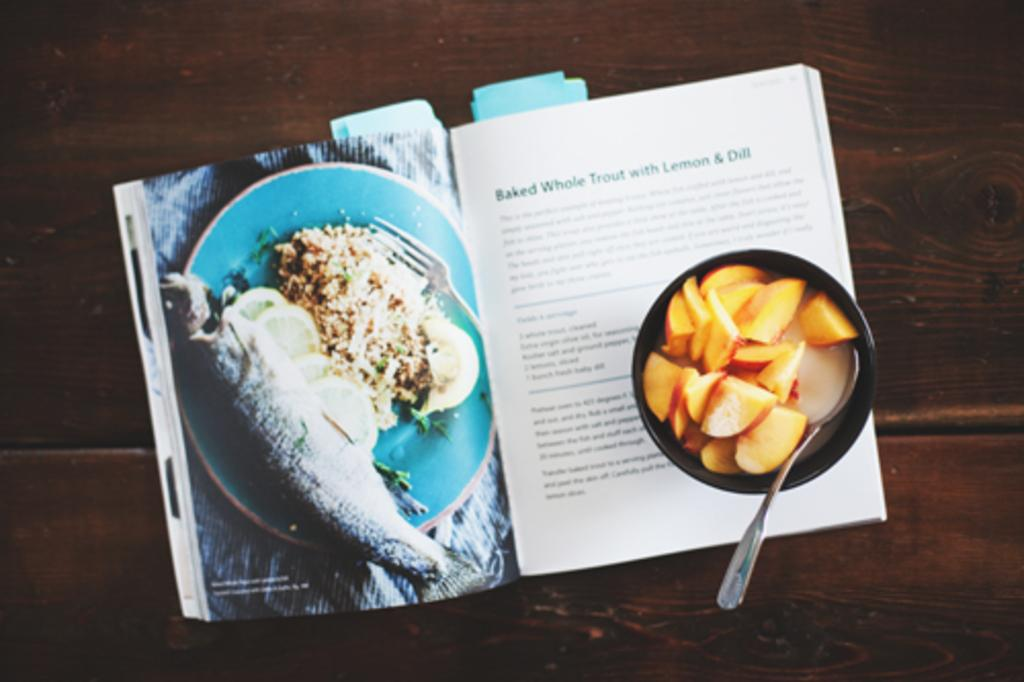<image>
Provide a brief description of the given image. Magazine about Baked Whole Trout with Lemon and Dill. 